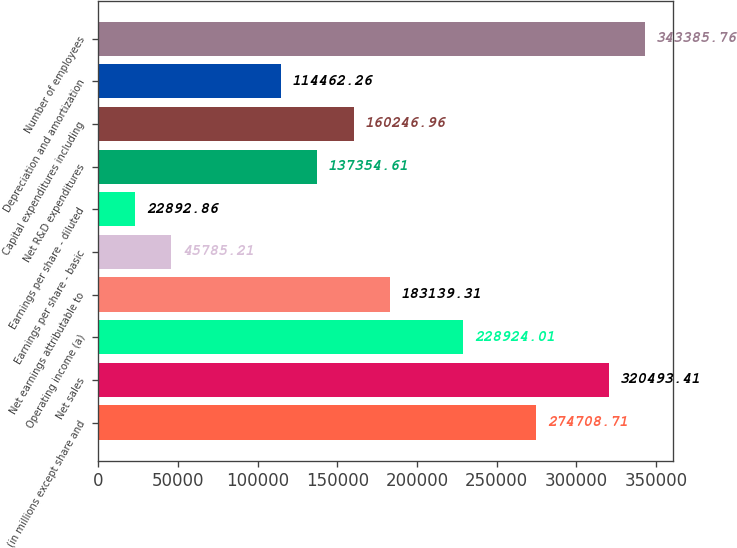<chart> <loc_0><loc_0><loc_500><loc_500><bar_chart><fcel>(in millions except share and<fcel>Net sales<fcel>Operating income (a)<fcel>Net earnings attributable to<fcel>Earnings per share - basic<fcel>Earnings per share - diluted<fcel>Net R&D expenditures<fcel>Capital expenditures including<fcel>Depreciation and amortization<fcel>Number of employees<nl><fcel>274709<fcel>320493<fcel>228924<fcel>183139<fcel>45785.2<fcel>22892.9<fcel>137355<fcel>160247<fcel>114462<fcel>343386<nl></chart> 